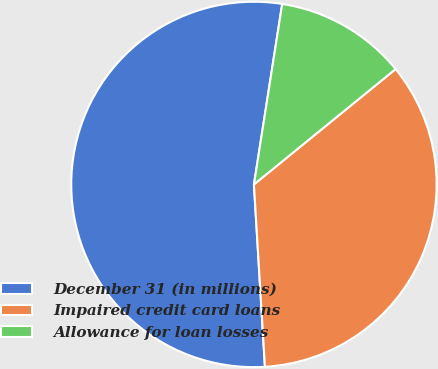Convert chart. <chart><loc_0><loc_0><loc_500><loc_500><pie_chart><fcel>December 31 (in millions)<fcel>Impaired credit card loans<fcel>Allowance for loan losses<nl><fcel>53.43%<fcel>34.92%<fcel>11.65%<nl></chart> 